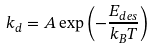Convert formula to latex. <formula><loc_0><loc_0><loc_500><loc_500>k _ { d } = A \exp \left ( { - { \frac { { E _ { d e s } } } { { k _ { B } T } } } } \right )</formula> 